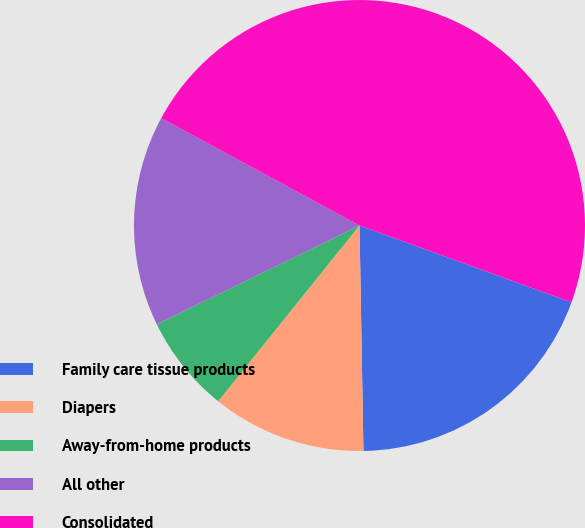Convert chart. <chart><loc_0><loc_0><loc_500><loc_500><pie_chart><fcel>Family care tissue products<fcel>Diapers<fcel>Away-from-home products<fcel>All other<fcel>Consolidated<nl><fcel>19.19%<fcel>11.06%<fcel>7.0%<fcel>15.12%<fcel>47.63%<nl></chart> 